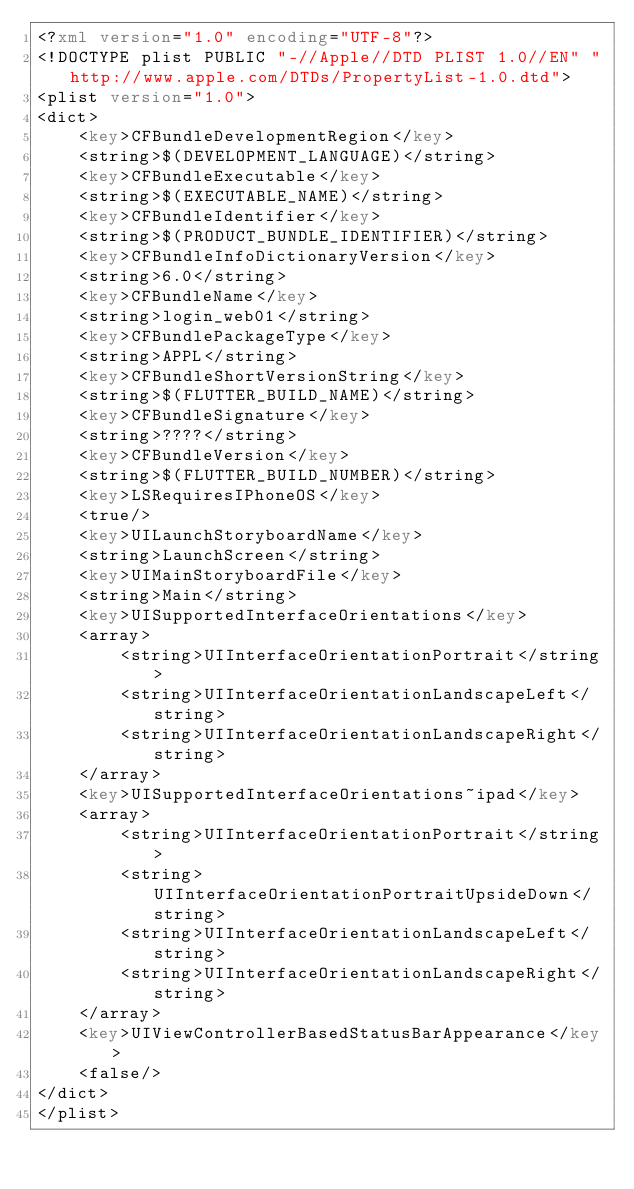<code> <loc_0><loc_0><loc_500><loc_500><_XML_><?xml version="1.0" encoding="UTF-8"?>
<!DOCTYPE plist PUBLIC "-//Apple//DTD PLIST 1.0//EN" "http://www.apple.com/DTDs/PropertyList-1.0.dtd">
<plist version="1.0">
<dict>
	<key>CFBundleDevelopmentRegion</key>
	<string>$(DEVELOPMENT_LANGUAGE)</string>
	<key>CFBundleExecutable</key>
	<string>$(EXECUTABLE_NAME)</string>
	<key>CFBundleIdentifier</key>
	<string>$(PRODUCT_BUNDLE_IDENTIFIER)</string>
	<key>CFBundleInfoDictionaryVersion</key>
	<string>6.0</string>
	<key>CFBundleName</key>
	<string>login_web01</string>
	<key>CFBundlePackageType</key>
	<string>APPL</string>
	<key>CFBundleShortVersionString</key>
	<string>$(FLUTTER_BUILD_NAME)</string>
	<key>CFBundleSignature</key>
	<string>????</string>
	<key>CFBundleVersion</key>
	<string>$(FLUTTER_BUILD_NUMBER)</string>
	<key>LSRequiresIPhoneOS</key>
	<true/>
	<key>UILaunchStoryboardName</key>
	<string>LaunchScreen</string>
	<key>UIMainStoryboardFile</key>
	<string>Main</string>
	<key>UISupportedInterfaceOrientations</key>
	<array>
		<string>UIInterfaceOrientationPortrait</string>
		<string>UIInterfaceOrientationLandscapeLeft</string>
		<string>UIInterfaceOrientationLandscapeRight</string>
	</array>
	<key>UISupportedInterfaceOrientations~ipad</key>
	<array>
		<string>UIInterfaceOrientationPortrait</string>
		<string>UIInterfaceOrientationPortraitUpsideDown</string>
		<string>UIInterfaceOrientationLandscapeLeft</string>
		<string>UIInterfaceOrientationLandscapeRight</string>
	</array>
	<key>UIViewControllerBasedStatusBarAppearance</key>
	<false/>
</dict>
</plist>
</code> 